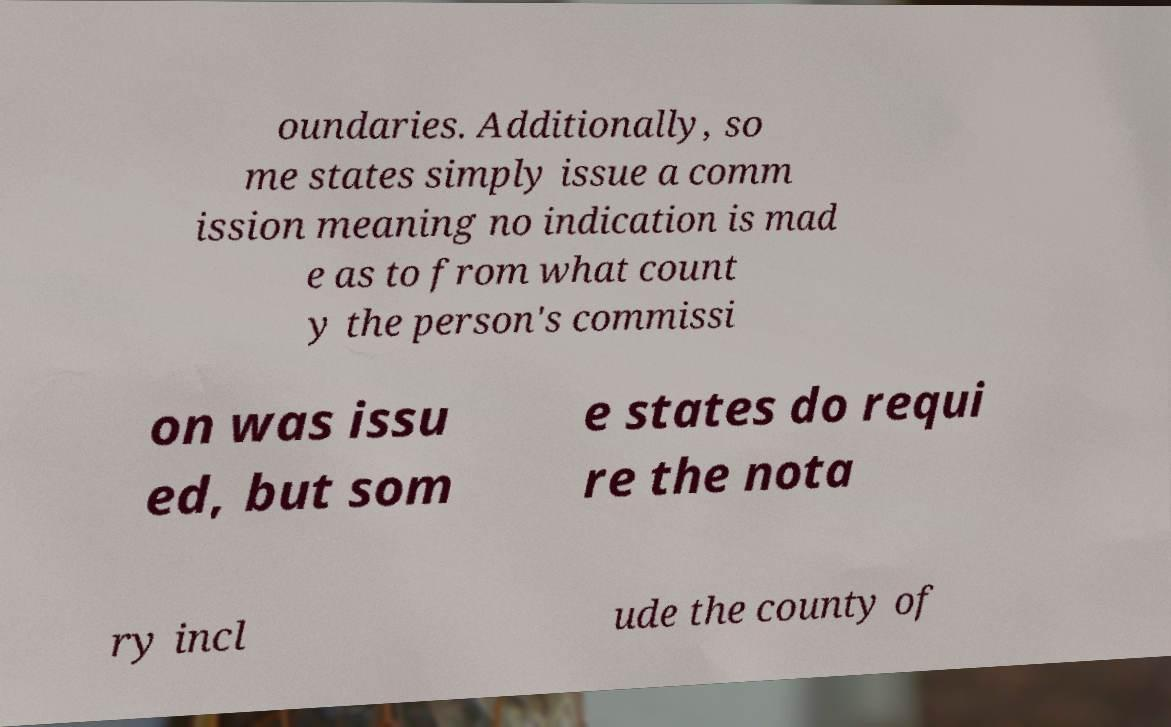For documentation purposes, I need the text within this image transcribed. Could you provide that? oundaries. Additionally, so me states simply issue a comm ission meaning no indication is mad e as to from what count y the person's commissi on was issu ed, but som e states do requi re the nota ry incl ude the county of 